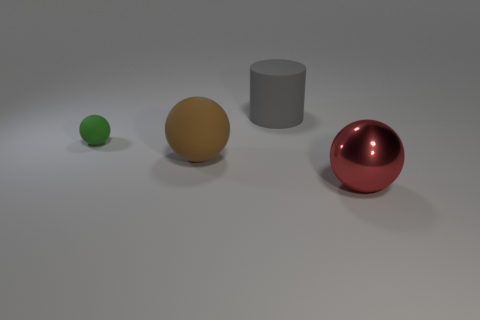Subtract all gray balls. Subtract all green cubes. How many balls are left? 3 Add 3 small purple matte cylinders. How many objects exist? 7 Subtract all balls. How many objects are left? 1 Add 1 matte things. How many matte things are left? 4 Add 2 rubber cylinders. How many rubber cylinders exist? 3 Subtract 0 green blocks. How many objects are left? 4 Subtract all tiny red metallic things. Subtract all big brown matte things. How many objects are left? 3 